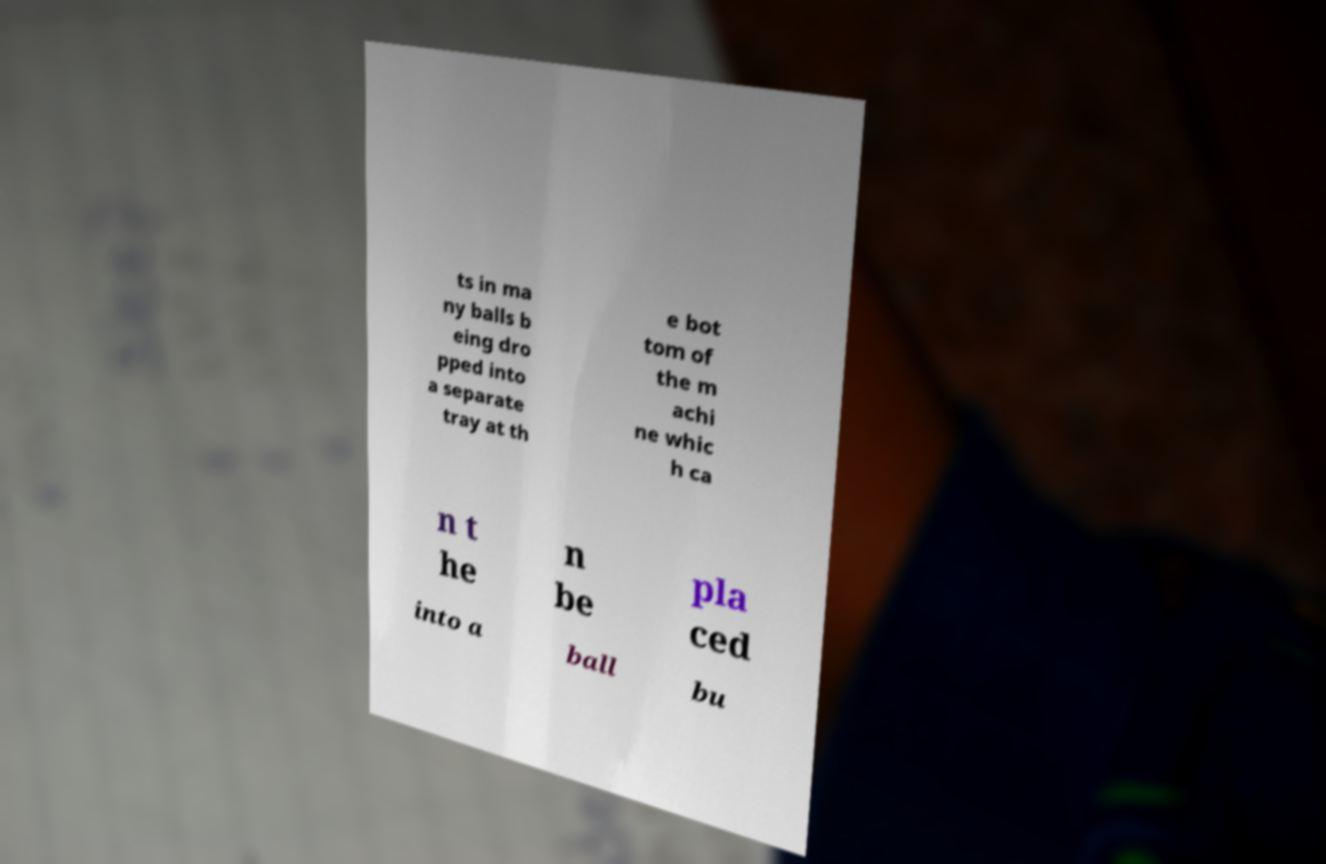There's text embedded in this image that I need extracted. Can you transcribe it verbatim? ts in ma ny balls b eing dro pped into a separate tray at th e bot tom of the m achi ne whic h ca n t he n be pla ced into a ball bu 